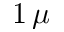Convert formula to latex. <formula><loc_0><loc_0><loc_500><loc_500>1 \, \mu</formula> 